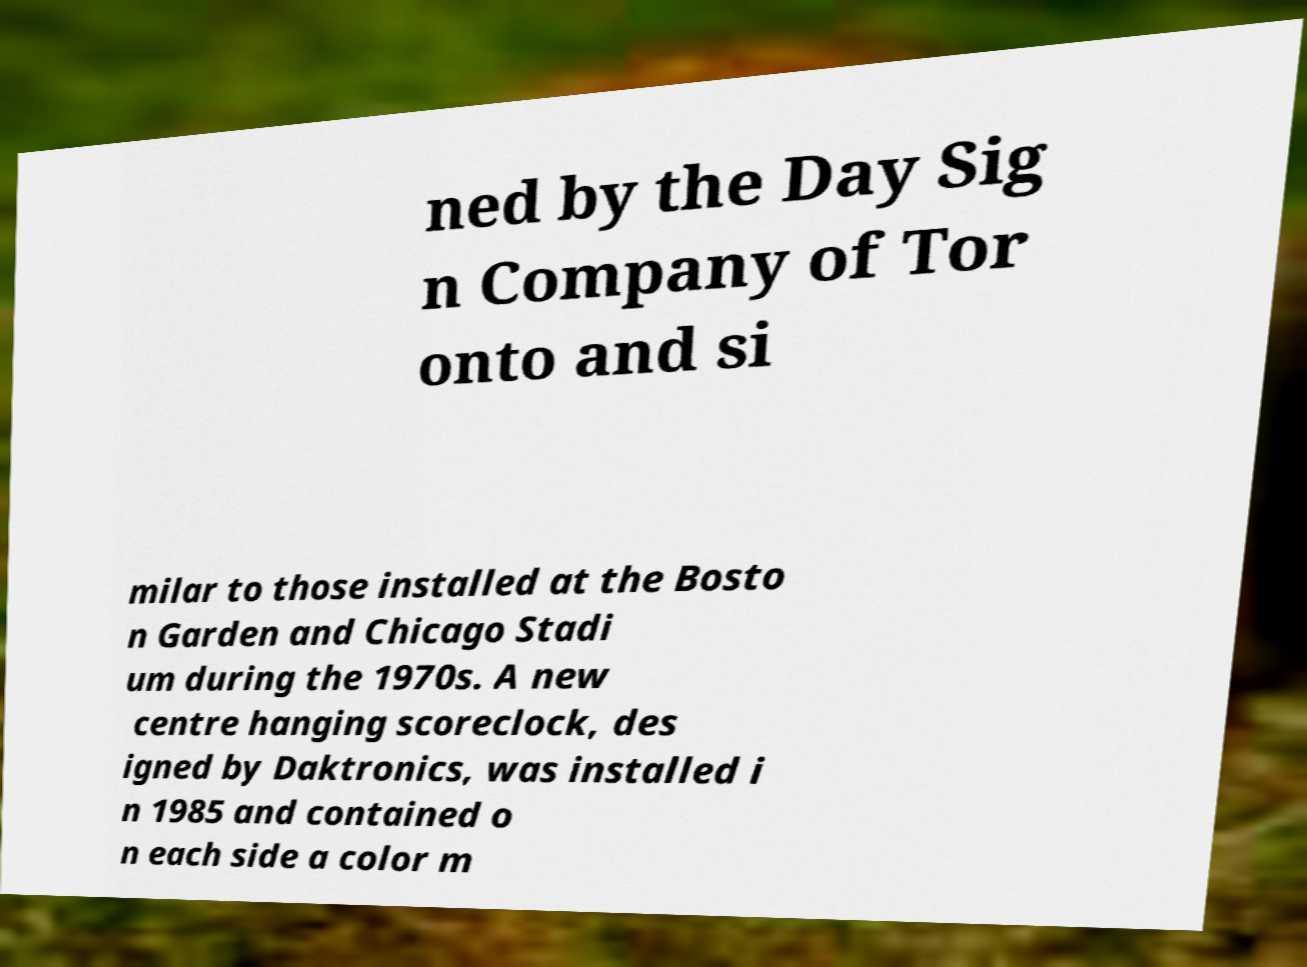Can you accurately transcribe the text from the provided image for me? ned by the Day Sig n Company of Tor onto and si milar to those installed at the Bosto n Garden and Chicago Stadi um during the 1970s. A new centre hanging scoreclock, des igned by Daktronics, was installed i n 1985 and contained o n each side a color m 